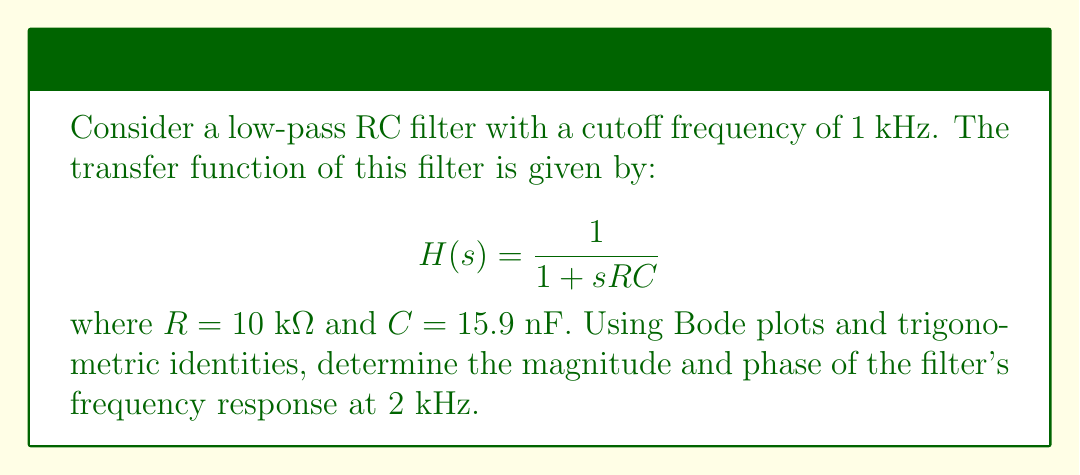Solve this math problem. 1. First, we need to calculate the cutoff frequency $\omega_c$ in rad/s:
   $$\omega_c = 2\pi f_c = 2\pi \cdot 1000 = 6283.19 \text{ rad/s}$$

2. The frequency of interest is 2 kHz, which in rad/s is:
   $$\omega = 2\pi \cdot 2000 = 12566.37 \text{ rad/s}$$

3. The normalized frequency is:
   $$\frac{\omega}{\omega_c} = \frac{12566.37}{6283.19} = 2$$

4. For a first-order low-pass filter, the magnitude response in dB is given by:
   $$|H(j\omega)|_{dB} = -20 \log_{10}\sqrt{1 + (\frac{\omega}{\omega_c})^2}$$

   Substituting the normalized frequency:
   $$|H(j\omega)|_{dB} = -20 \log_{10}\sqrt{1 + 2^2} = -20 \log_{10}\sqrt{5} = -6.99 \text{ dB}$$

5. The phase response is given by:
   $$\angle H(j\omega) = -\tan^{-1}(\frac{\omega}{\omega_c})$$

   Substituting the normalized frequency:
   $$\angle H(j\omega) = -\tan^{-1}(2) = -63.43°$$

6. To convert the magnitude from dB to linear scale, we use:
   $$|H(j\omega)| = 10^{\frac{|H(j\omega)|_{dB}}{20}} = 10^{\frac{-6.99}{20}} = 0.4472$$

7. Using trigonometric identities, we can express the complex transfer function as:
   $$H(j\omega) = |H(j\omega)| \cdot (\cos(\angle H(j\omega)) + j \sin(\angle H(j\omega)))$$
   $$H(j\omega) = 0.4472 \cdot (\cos(-63.43°) + j \sin(-63.43°))$$
   $$H(j\omega) = 0.2 - j0.4$$
Answer: $H(j\omega) = 0.2 - j0.4$ 